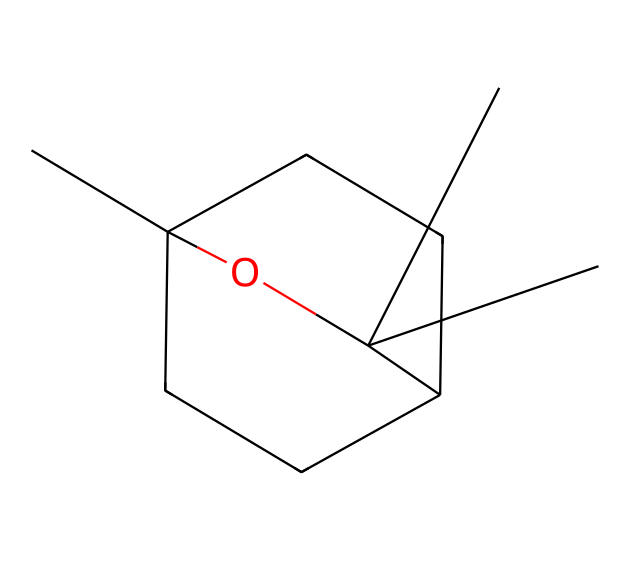What is the molecular formula of eucalyptol? To determine the molecular formula, count the number of carbon (C), hydrogen (H), and oxygen (O) atoms in the structure. The molecular structure indicates there are 10 carbon atoms, 18 hydrogen atoms, and 1 oxygen atom. Therefore, the molecular formula is C10H18O.
Answer: C10H18O How many rings are present in the eucalyptol structure? Observing the structure, we see two cyclic components. The "CC12CCC(CC1)" part indicates that there are two interconnected rings in the molecule. Thus, the structure contains 2 rings.
Answer: 2 rings What type of functional group is present in eucalyptol? The structure features a hydroxyl group (–OH) as indicated by the "O" atom connected to the carbon. This is characteristic of alcohols, classifying eucalyptol as an alcohol.
Answer: alcohol What is the primary type of compound eucalyptol is classified as? Eucalyptol has a hydrocarbon framework associated with terpenes, and given its distinct bicyclic structure, it is classified specifically as a monoterpene. Therefore, eucalyptol is a monoterpene.
Answer: monoterpene How many hydrogen atoms are attached to the carbon atom with the hydroxyl group? Looking at the structure, the carbon attached to the hydroxyl group does not have attached hydrogen atoms, as it is fully saturated by its connections. Therefore, there are 0 hydrogen atoms on that specific carbon.
Answer: 0 Is eucalyptol chiral? To determine chirality, we look for a carbon that has four distinct substituents. In the given structure, no such carbon exists; thus, eucalyptol is not chiral.
Answer: no 